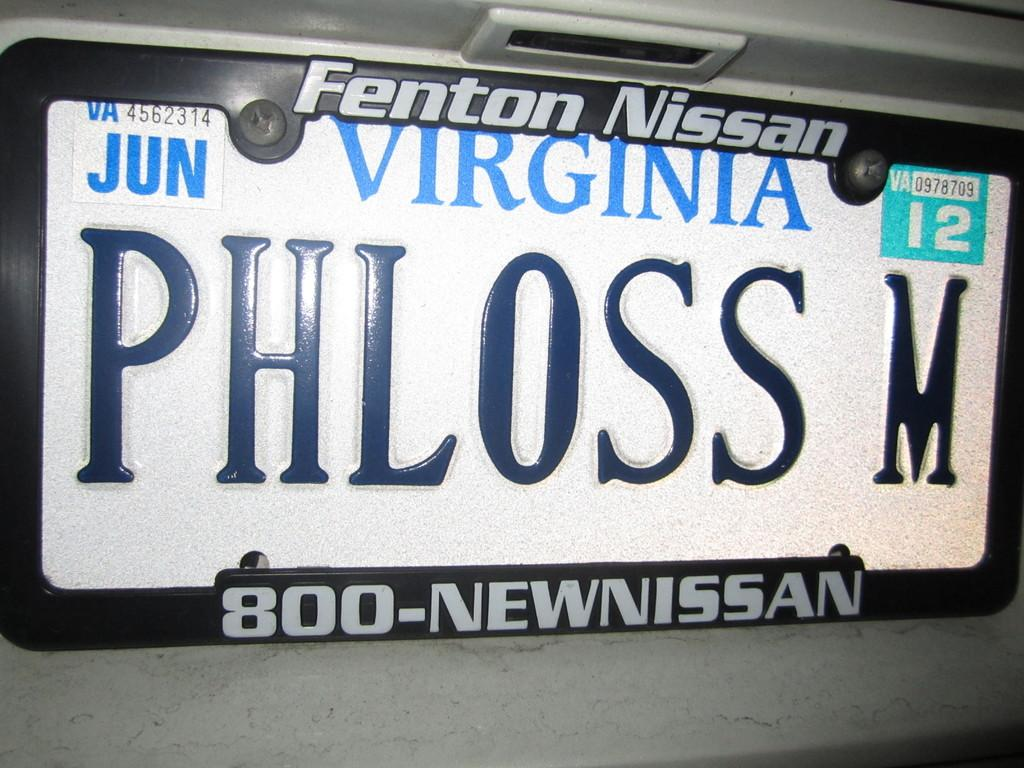Provide a one-sentence caption for the provided image. The Virginia license plate says PHLOSS M and is on  Nissan. 